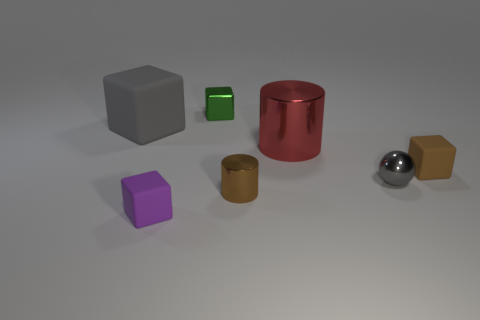Subtract 1 cubes. How many cubes are left? 3 Subtract all red cubes. Subtract all blue balls. How many cubes are left? 4 Add 1 big gray blocks. How many objects exist? 8 Subtract all cubes. How many objects are left? 3 Add 7 purple things. How many purple things are left? 8 Add 2 purple objects. How many purple objects exist? 3 Subtract 1 gray cubes. How many objects are left? 6 Subtract all big gray blocks. Subtract all small green cubes. How many objects are left? 5 